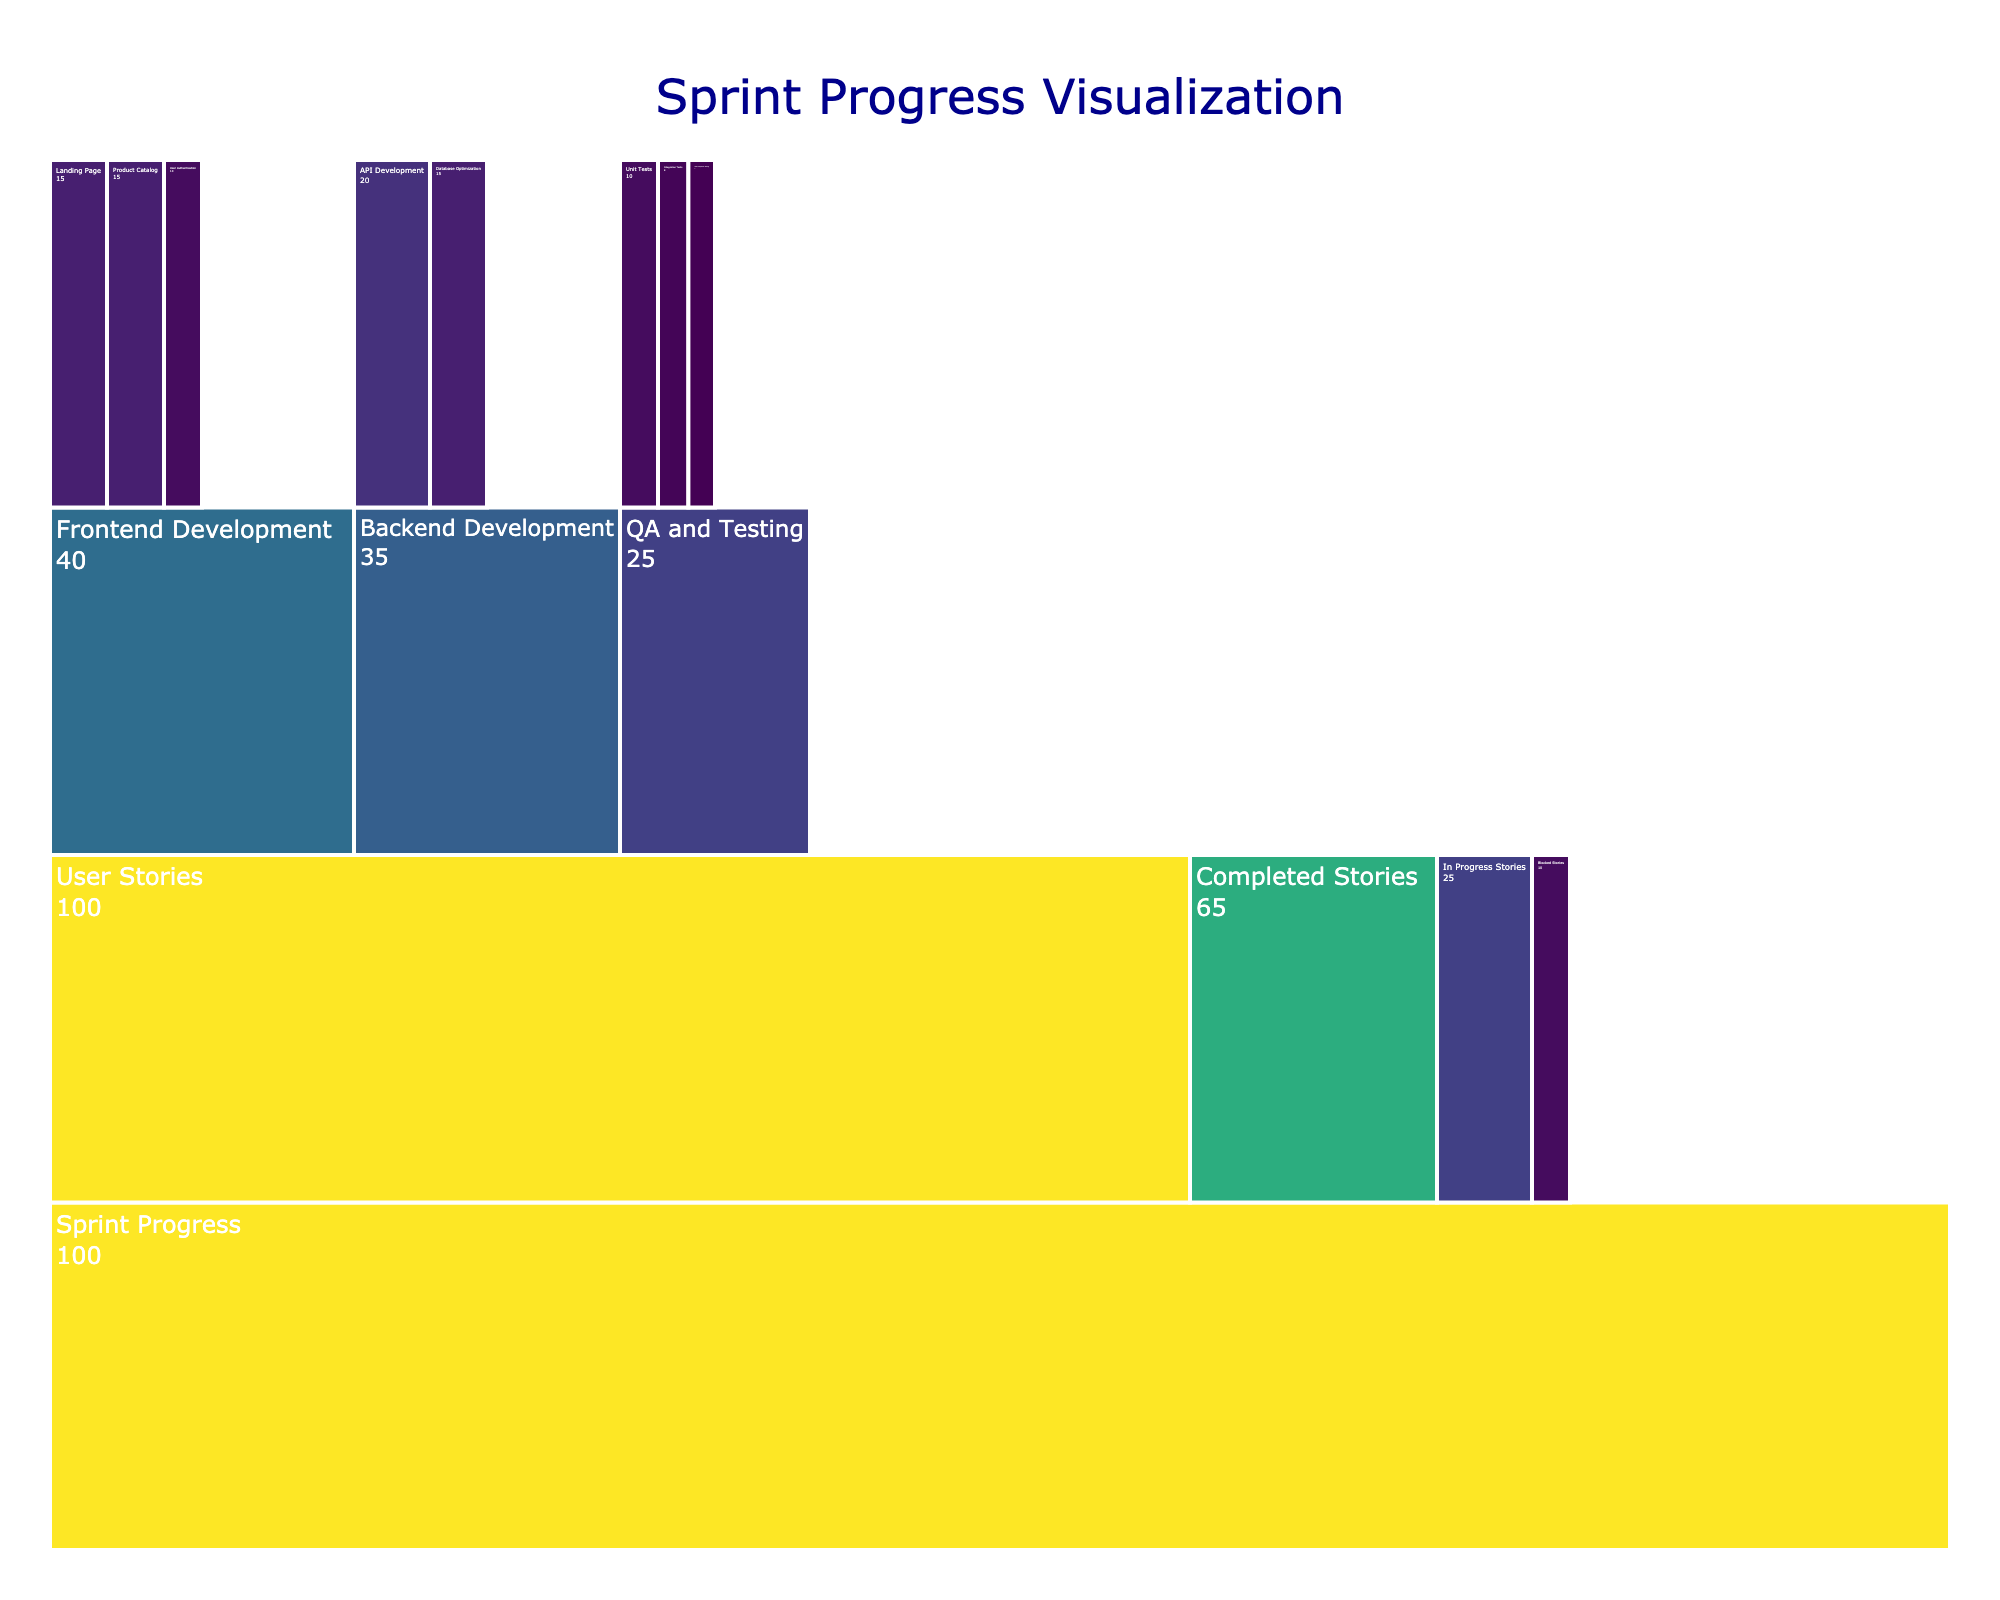What is the title of the Icicle Chart? The title is located at the top of the Icicle Chart and usually describes the purpose of the chart. From our figure constraints, the title is "Sprint Progress Visualization."
Answer: Sprint Progress Visualization How many main categories are directly under "Sprint Progress"? By examining the chart, we can see the first level of categorization under "Sprint Progress." These categories are "User Stories," "Completed Stories," "In Progress Stories," and "Blocked Stories," making a total of four main categories.
Answer: 4 Which user story under "Frontend Development" has the highest value? By looking at the "Frontend Development" section, we can see the values of each user story. "Landing Page" has a value of 15, "User Authentication" has a value of 10, and "Product Catalog" has a value of 15. Both "Landing Page" and "Product Catalog" have the highest value of 15.
Answer: Landing Page and Product Catalog What is the combined value of "Backend Development" user stories? We need to add the values of all user stories under "Backend Development." "API Development" has a value of 20, and "Database Optimization" has a value of 15. Adding them together, 20 + 15 = 35.
Answer: 35 How does the value of "QA and Testing" compare to the value of "Blocked Stories"? From the chart, "QA and Testing" has a value of 25, and "Blocked Stories" has a value of 10. Comparing the two, "QA and Testing" is greater than "Blocked Stories."
Answer: Greater than What percentage of the "User Stories" are completed? The total value of "User Stories" is 100. "Completed Stories" has a value of 65. To find the percentage completed: (65 / 100) * 100 = 65%.
Answer: 65% What is the value difference between "User Acceptance Testing" and "Unit Tests"? "User Acceptance Testing" has a value of 7, while "Unit Tests" has a value of 10. The difference is 10 - 7 = 3.
Answer: 3 Which has more progress reported: "Frontend Development" or "Backend Development"? Comparing the values, "Frontend Development" has a value of 40, and "Backend Development" has a value of 35. Thus, "Frontend Development" has more reported progress.
Answer: Frontend Development How many stories are marked as "In Progress"? According to the chart, the value for "In Progress Stories" under "Sprint Progress" is shown as 25.
Answer: 25 